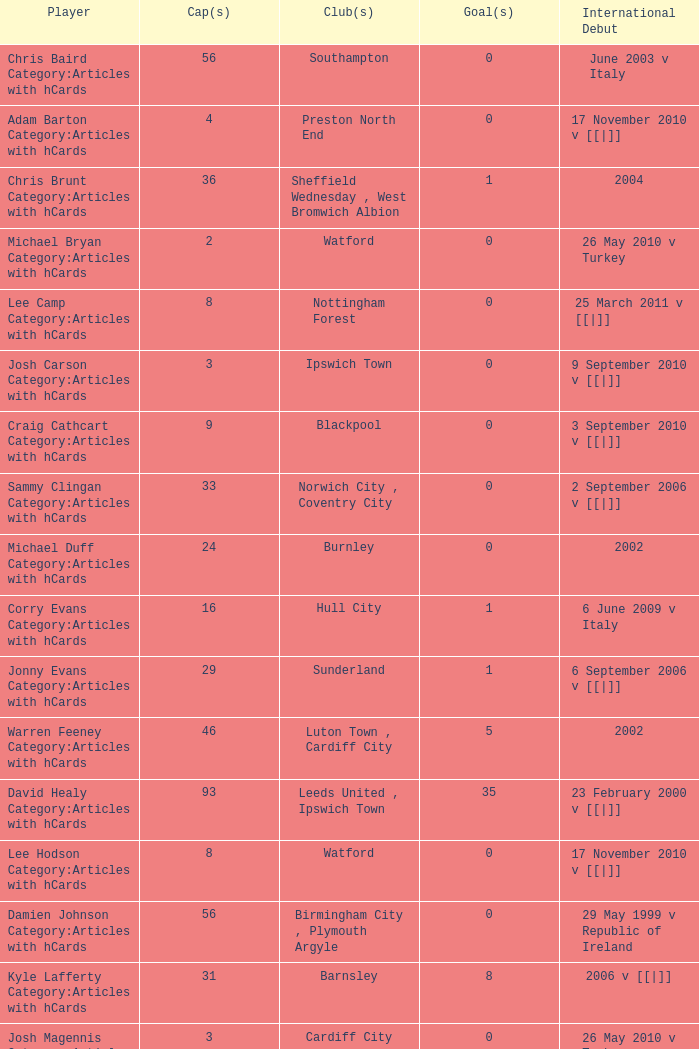How many caps figures for the Doncaster Rovers? 1.0. 